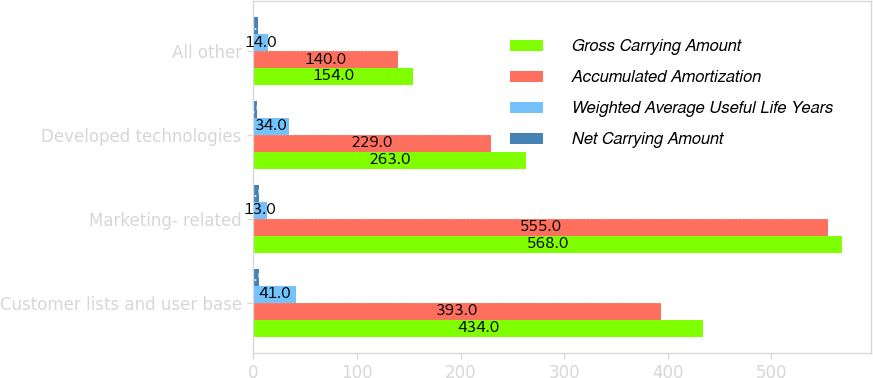Convert chart to OTSL. <chart><loc_0><loc_0><loc_500><loc_500><stacked_bar_chart><ecel><fcel>Customer lists and user base<fcel>Marketing- related<fcel>Developed technologies<fcel>All other<nl><fcel>Gross Carrying Amount<fcel>434<fcel>568<fcel>263<fcel>154<nl><fcel>Accumulated Amortization<fcel>393<fcel>555<fcel>229<fcel>140<nl><fcel>Weighted Average Useful Life Years<fcel>41<fcel>13<fcel>34<fcel>14<nl><fcel>Net Carrying Amount<fcel>5<fcel>5<fcel>3<fcel>4<nl></chart> 